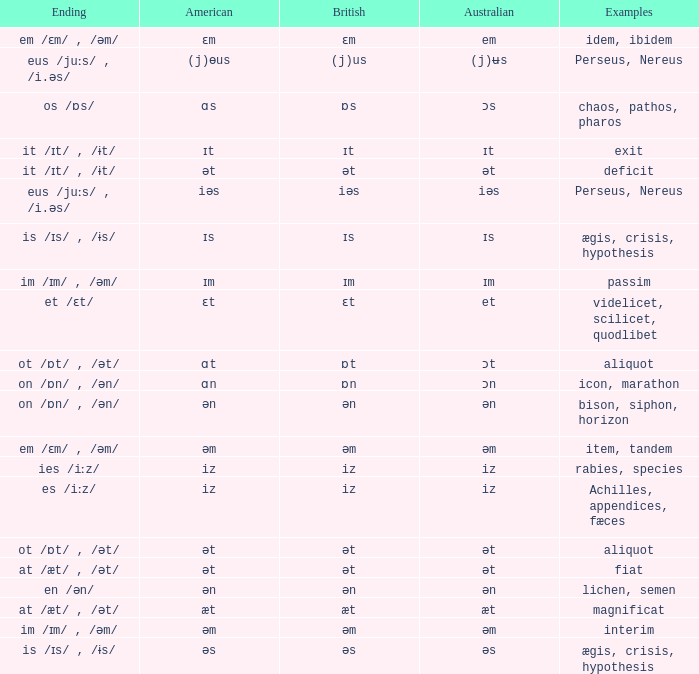Would you mind parsing the complete table? {'header': ['Ending', 'American', 'British', 'Australian', 'Examples'], 'rows': [['em /ɛm/ , /əm/', 'ɛm', 'ɛm', 'em', 'idem, ibidem'], ['eus /juːs/ , /i.əs/', '(j)ɵus', '(j)us', '(j)ʉs', 'Perseus, Nereus'], ['os /ɒs/', 'ɑs', 'ɒs', 'ɔs', 'chaos, pathos, pharos'], ['it /ɪt/ , /ɨt/', 'ɪt', 'ɪt', 'ɪt', 'exit'], ['it /ɪt/ , /ɨt/', 'ət', 'ət', 'ət', 'deficit'], ['eus /juːs/ , /i.əs/', 'iəs', 'iəs', 'iəs', 'Perseus, Nereus'], ['is /ɪs/ , /ɨs/', 'ɪs', 'ɪs', 'ɪs', 'ægis, crisis, hypothesis'], ['im /ɪm/ , /əm/', 'ɪm', 'ɪm', 'ɪm', 'passim'], ['et /ɛt/', 'ɛt', 'ɛt', 'et', 'videlicet, scilicet, quodlibet'], ['ot /ɒt/ , /ət/', 'ɑt', 'ɒt', 'ɔt', 'aliquot'], ['on /ɒn/ , /ən/', 'ɑn', 'ɒn', 'ɔn', 'icon, marathon'], ['on /ɒn/ , /ən/', 'ən', 'ən', 'ən', 'bison, siphon, horizon'], ['em /ɛm/ , /əm/', 'əm', 'əm', 'əm', 'item, tandem'], ['ies /iːz/', 'iz', 'iz', 'iz', 'rabies, species'], ['es /iːz/', 'iz', 'iz', 'iz', 'Achilles, appendices, fæces'], ['ot /ɒt/ , /ət/', 'ət', 'ət', 'ət', 'aliquot'], ['at /æt/ , /ət/', 'ət', 'ət', 'ət', 'fiat'], ['en /ən/', 'ən', 'ən', 'ən', 'lichen, semen'], ['at /æt/ , /ət/', 'æt', 'æt', 'æt', 'magnificat'], ['im /ɪm/ , /əm/', 'əm', 'əm', 'əm', 'interim'], ['is /ɪs/ , /ɨs/', 'əs', 'əs', 'əs', 'ægis, crisis, hypothesis']]} Which Australian has British of ɒs? Ɔs. 